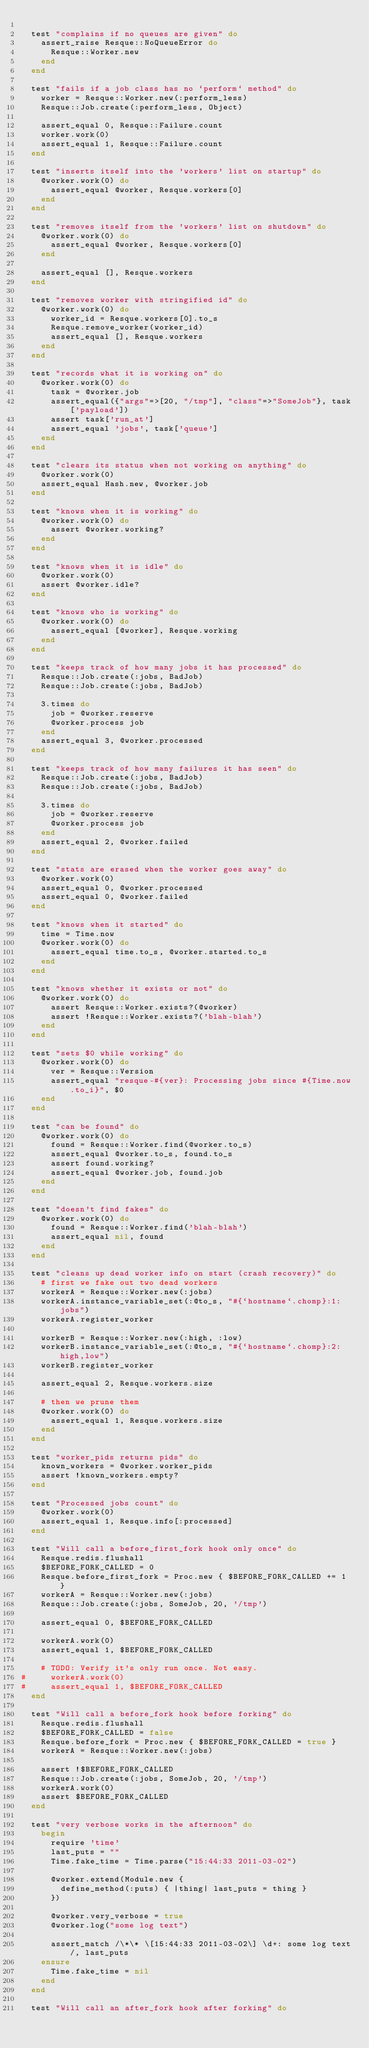Convert code to text. <code><loc_0><loc_0><loc_500><loc_500><_Ruby_>
  test "complains if no queues are given" do
    assert_raise Resque::NoQueueError do
      Resque::Worker.new
    end
  end

  test "fails if a job class has no `perform` method" do
    worker = Resque::Worker.new(:perform_less)
    Resque::Job.create(:perform_less, Object)

    assert_equal 0, Resque::Failure.count
    worker.work(0)
    assert_equal 1, Resque::Failure.count
  end

  test "inserts itself into the 'workers' list on startup" do
    @worker.work(0) do
      assert_equal @worker, Resque.workers[0]
    end
  end

  test "removes itself from the 'workers' list on shutdown" do
    @worker.work(0) do
      assert_equal @worker, Resque.workers[0]
    end

    assert_equal [], Resque.workers
  end

  test "removes worker with stringified id" do
    @worker.work(0) do
      worker_id = Resque.workers[0].to_s
      Resque.remove_worker(worker_id)
      assert_equal [], Resque.workers
    end
  end

  test "records what it is working on" do
    @worker.work(0) do
      task = @worker.job
      assert_equal({"args"=>[20, "/tmp"], "class"=>"SomeJob"}, task['payload'])
      assert task['run_at']
      assert_equal 'jobs', task['queue']
    end
  end

  test "clears its status when not working on anything" do
    @worker.work(0)
    assert_equal Hash.new, @worker.job
  end

  test "knows when it is working" do
    @worker.work(0) do
      assert @worker.working?
    end
  end

  test "knows when it is idle" do
    @worker.work(0)
    assert @worker.idle?
  end

  test "knows who is working" do
    @worker.work(0) do
      assert_equal [@worker], Resque.working
    end
  end

  test "keeps track of how many jobs it has processed" do
    Resque::Job.create(:jobs, BadJob)
    Resque::Job.create(:jobs, BadJob)

    3.times do
      job = @worker.reserve
      @worker.process job
    end
    assert_equal 3, @worker.processed
  end

  test "keeps track of how many failures it has seen" do
    Resque::Job.create(:jobs, BadJob)
    Resque::Job.create(:jobs, BadJob)

    3.times do
      job = @worker.reserve
      @worker.process job
    end
    assert_equal 2, @worker.failed
  end

  test "stats are erased when the worker goes away" do
    @worker.work(0)
    assert_equal 0, @worker.processed
    assert_equal 0, @worker.failed
  end

  test "knows when it started" do
    time = Time.now
    @worker.work(0) do
      assert_equal time.to_s, @worker.started.to_s
    end
  end

  test "knows whether it exists or not" do
    @worker.work(0) do
      assert Resque::Worker.exists?(@worker)
      assert !Resque::Worker.exists?('blah-blah')
    end
  end

  test "sets $0 while working" do
    @worker.work(0) do
      ver = Resque::Version
      assert_equal "resque-#{ver}: Processing jobs since #{Time.now.to_i}", $0
    end
  end

  test "can be found" do
    @worker.work(0) do
      found = Resque::Worker.find(@worker.to_s)
      assert_equal @worker.to_s, found.to_s
      assert found.working?
      assert_equal @worker.job, found.job
    end
  end

  test "doesn't find fakes" do
    @worker.work(0) do
      found = Resque::Worker.find('blah-blah')
      assert_equal nil, found
    end
  end

  test "cleans up dead worker info on start (crash recovery)" do
    # first we fake out two dead workers
    workerA = Resque::Worker.new(:jobs)
    workerA.instance_variable_set(:@to_s, "#{`hostname`.chomp}:1:jobs")
    workerA.register_worker

    workerB = Resque::Worker.new(:high, :low)
    workerB.instance_variable_set(:@to_s, "#{`hostname`.chomp}:2:high,low")
    workerB.register_worker

    assert_equal 2, Resque.workers.size

    # then we prune them
    @worker.work(0) do
      assert_equal 1, Resque.workers.size
    end
  end

  test "worker_pids returns pids" do
    known_workers = @worker.worker_pids
    assert !known_workers.empty?
  end

  test "Processed jobs count" do
    @worker.work(0)
    assert_equal 1, Resque.info[:processed]
  end

  test "Will call a before_first_fork hook only once" do
    Resque.redis.flushall
    $BEFORE_FORK_CALLED = 0
    Resque.before_first_fork = Proc.new { $BEFORE_FORK_CALLED += 1 }
    workerA = Resque::Worker.new(:jobs)
    Resque::Job.create(:jobs, SomeJob, 20, '/tmp')

    assert_equal 0, $BEFORE_FORK_CALLED

    workerA.work(0)
    assert_equal 1, $BEFORE_FORK_CALLED

    # TODO: Verify it's only run once. Not easy.
#     workerA.work(0)
#     assert_equal 1, $BEFORE_FORK_CALLED
  end

  test "Will call a before_fork hook before forking" do
    Resque.redis.flushall
    $BEFORE_FORK_CALLED = false
    Resque.before_fork = Proc.new { $BEFORE_FORK_CALLED = true }
    workerA = Resque::Worker.new(:jobs)

    assert !$BEFORE_FORK_CALLED
    Resque::Job.create(:jobs, SomeJob, 20, '/tmp')
    workerA.work(0)
    assert $BEFORE_FORK_CALLED
  end

  test "very verbose works in the afternoon" do
    begin
      require 'time'
      last_puts = ""
      Time.fake_time = Time.parse("15:44:33 2011-03-02")

      @worker.extend(Module.new {
        define_method(:puts) { |thing| last_puts = thing }
      })

      @worker.very_verbose = true
      @worker.log("some log text")

      assert_match /\*\* \[15:44:33 2011-03-02\] \d+: some log text/, last_puts
    ensure
      Time.fake_time = nil
    end
  end

  test "Will call an after_fork hook after forking" do</code> 